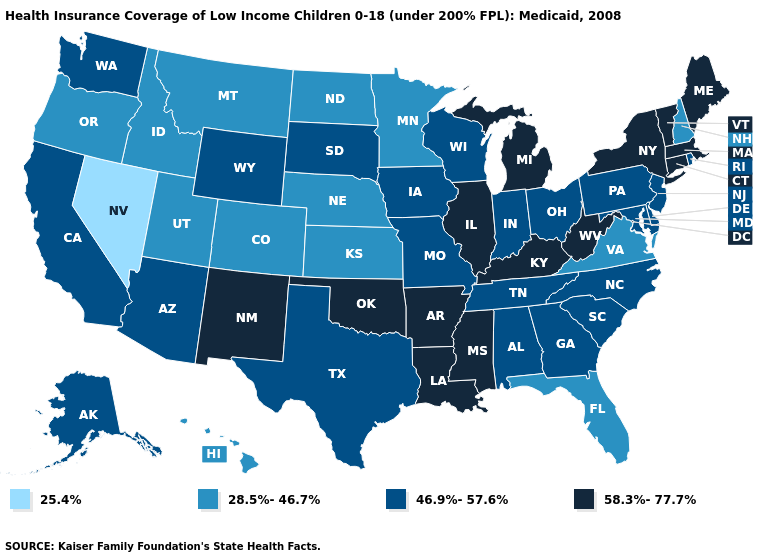Is the legend a continuous bar?
Give a very brief answer. No. Is the legend a continuous bar?
Quick response, please. No. Does Kentucky have a higher value than Connecticut?
Give a very brief answer. No. What is the highest value in states that border Arizona?
Give a very brief answer. 58.3%-77.7%. Does New Mexico have the highest value in the West?
Short answer required. Yes. What is the value of Montana?
Concise answer only. 28.5%-46.7%. Does Wyoming have the highest value in the USA?
Keep it brief. No. Among the states that border South Dakota , does North Dakota have the lowest value?
Give a very brief answer. Yes. What is the value of Wisconsin?
Answer briefly. 46.9%-57.6%. What is the value of Massachusetts?
Write a very short answer. 58.3%-77.7%. Among the states that border Arizona , which have the highest value?
Short answer required. New Mexico. What is the value of Pennsylvania?
Quick response, please. 46.9%-57.6%. What is the highest value in the USA?
Keep it brief. 58.3%-77.7%. How many symbols are there in the legend?
Give a very brief answer. 4. Name the states that have a value in the range 58.3%-77.7%?
Keep it brief. Arkansas, Connecticut, Illinois, Kentucky, Louisiana, Maine, Massachusetts, Michigan, Mississippi, New Mexico, New York, Oklahoma, Vermont, West Virginia. 